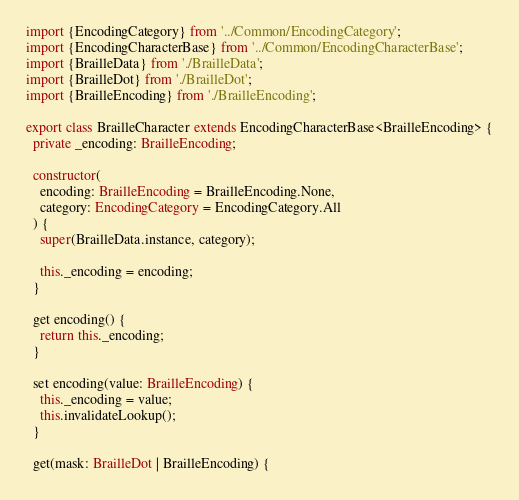<code> <loc_0><loc_0><loc_500><loc_500><_TypeScript_>import {EncodingCategory} from '../Common/EncodingCategory';
import {EncodingCharacterBase} from '../Common/EncodingCharacterBase';
import {BrailleData} from './BrailleData';
import {BrailleDot} from './BrailleDot';
import {BrailleEncoding} from './BrailleEncoding';

export class BrailleCharacter extends EncodingCharacterBase<BrailleEncoding> {
  private _encoding: BrailleEncoding;

  constructor(
    encoding: BrailleEncoding = BrailleEncoding.None,
    category: EncodingCategory = EncodingCategory.All
  ) {
    super(BrailleData.instance, category);

    this._encoding = encoding;
  }

  get encoding() {
    return this._encoding;
  }

  set encoding(value: BrailleEncoding) {
    this._encoding = value;
    this.invalidateLookup();
  }

  get(mask: BrailleDot | BrailleEncoding) {</code> 